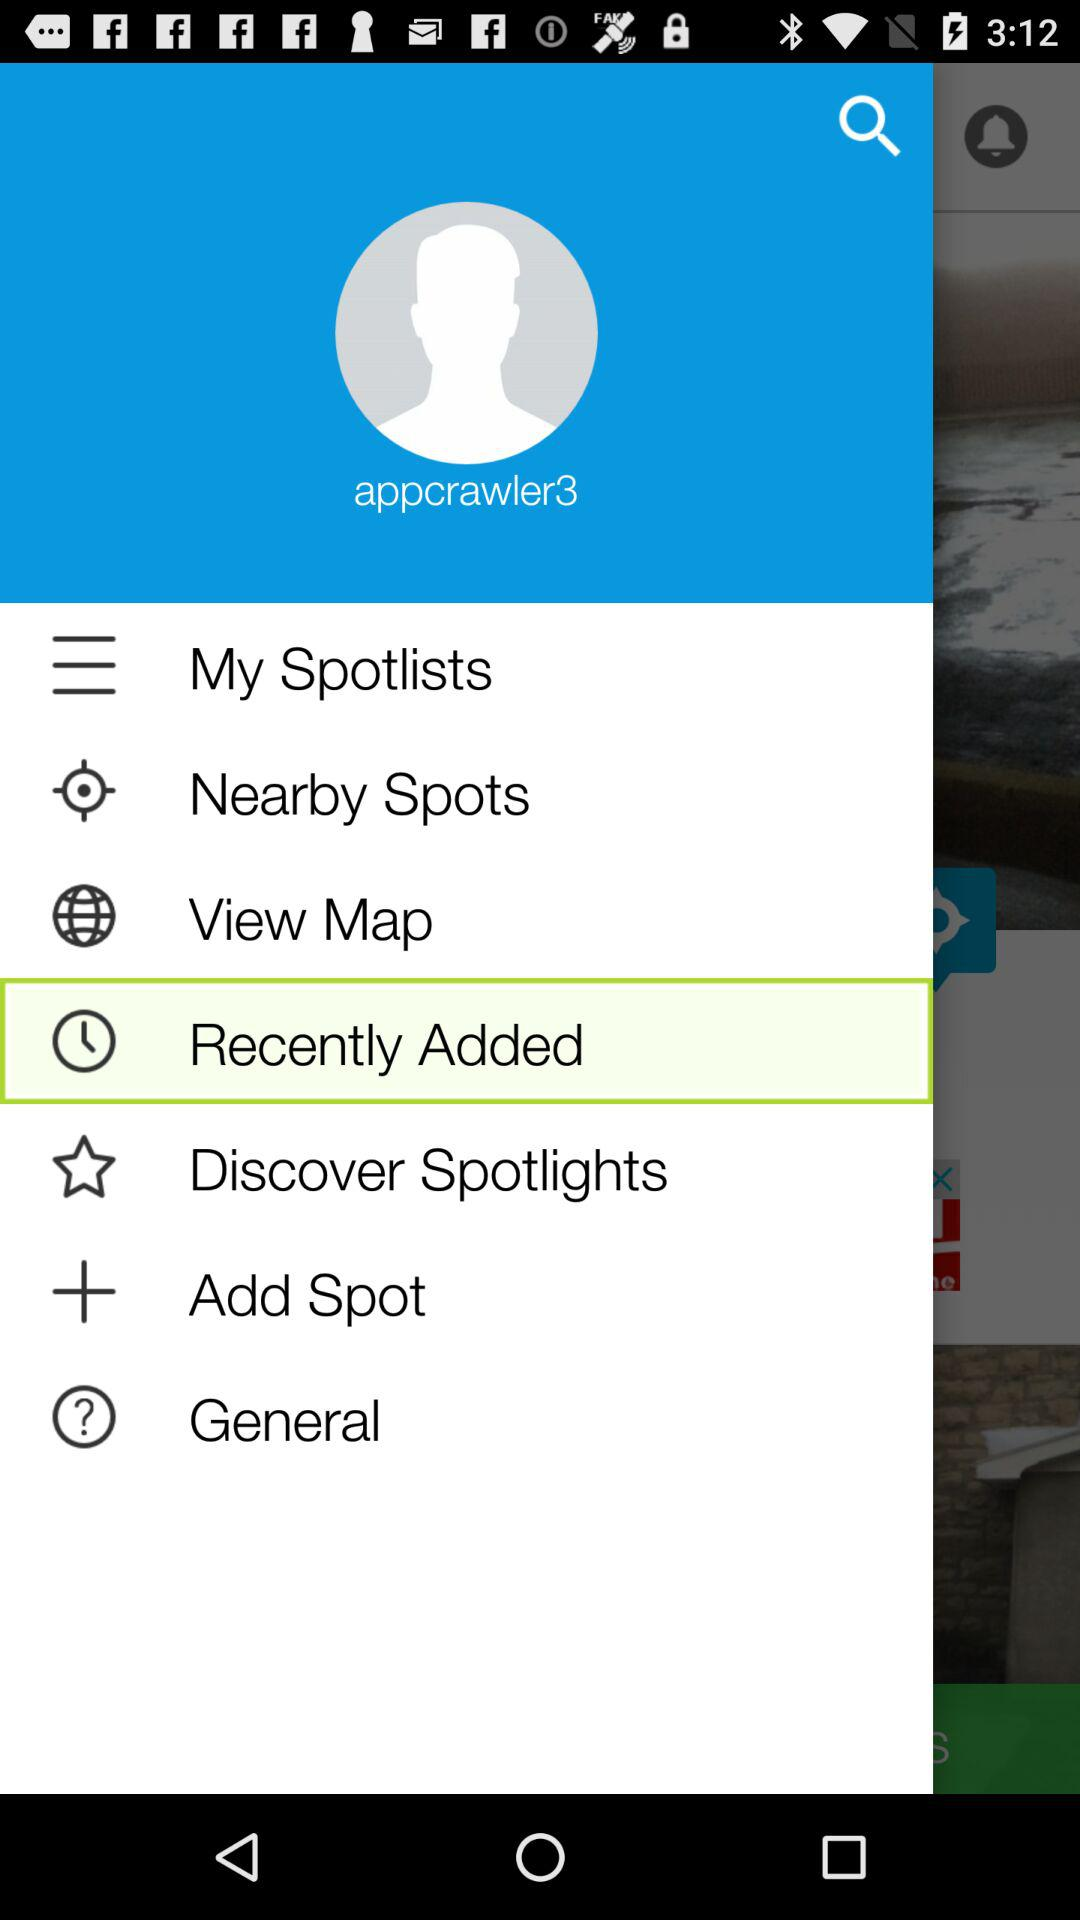What is the username? The username is "appcrawler3". 